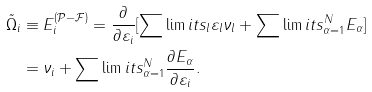<formula> <loc_0><loc_0><loc_500><loc_500>\tilde { \Omega } _ { i } & \equiv E _ { i } ^ { ( \mathcal { P - F } ) } = \frac { \partial } { \partial \varepsilon _ { i } } [ \sum \lim i t s _ { l } \varepsilon _ { l } \nu _ { l } + \sum \lim i t s _ { \alpha = 1 } ^ { N } E _ { \alpha } ] \\ & = \nu _ { i } + \sum \lim i t s _ { \alpha = 1 } ^ { N } \frac { \partial E _ { \alpha } } { \partial \varepsilon _ { i } } .</formula> 